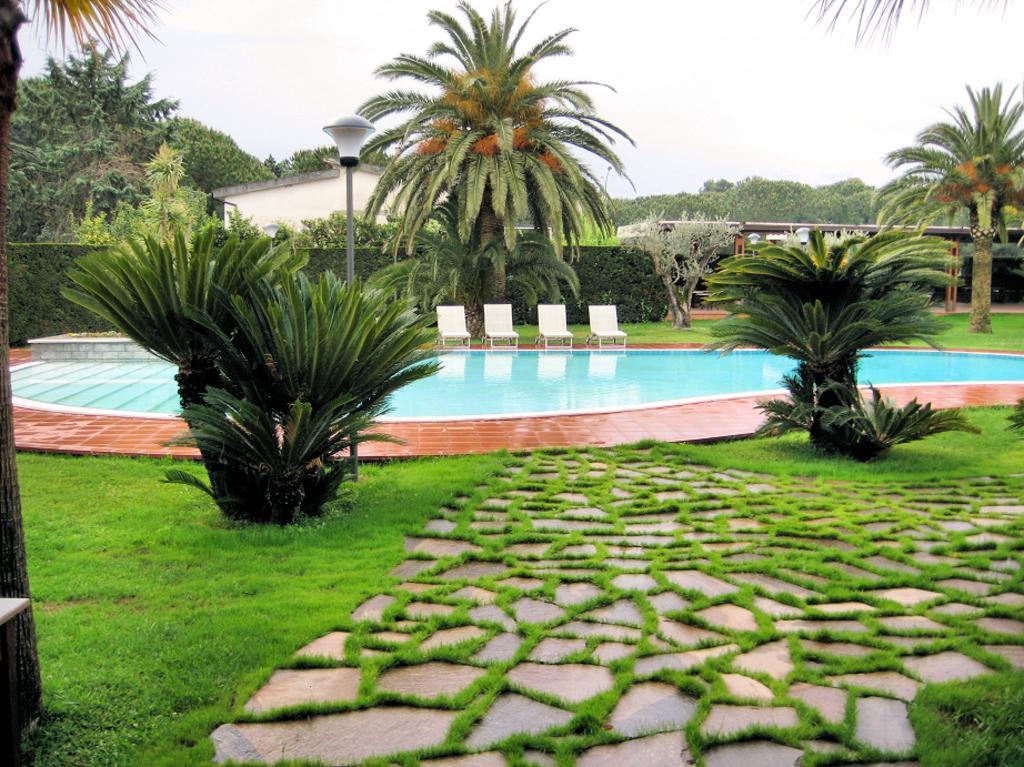Describe this image in one or two sentences. In this image at the bottom there is a grass and walkway, and also we could see some plants and there is a swimming pool, chairs, plants, trees and houses and there is a pole and light. And at the top of the image there is sky. 